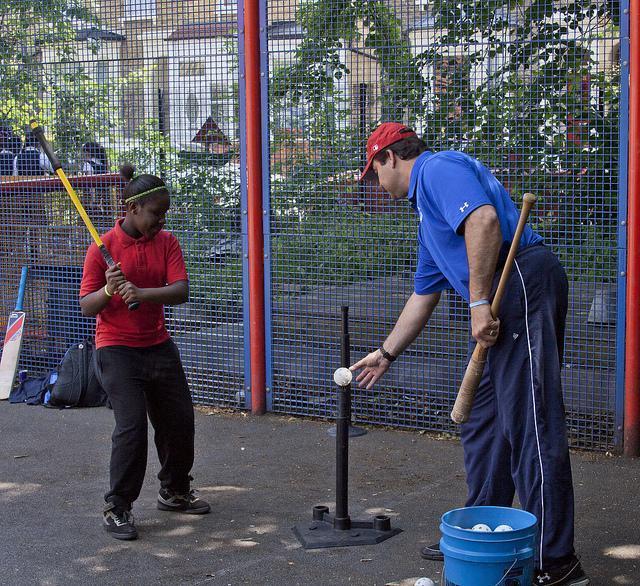How many people can you see?
Give a very brief answer. 3. 